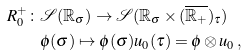<formula> <loc_0><loc_0><loc_500><loc_500>R _ { 0 } ^ { + } \colon & { \mathcal { S } } ( { \mathbb { R } } _ { \sigma } ) \rightarrow { \mathcal { S } } ( { \mathbb { R } } _ { \sigma } \times ( \overline { { \mathbb { R } } _ { + } } ) _ { \tau } ) \\ & \phi ( \sigma ) \mapsto \phi ( \sigma ) u _ { 0 } ( \tau ) = \phi \otimes u _ { 0 } \, ,</formula> 